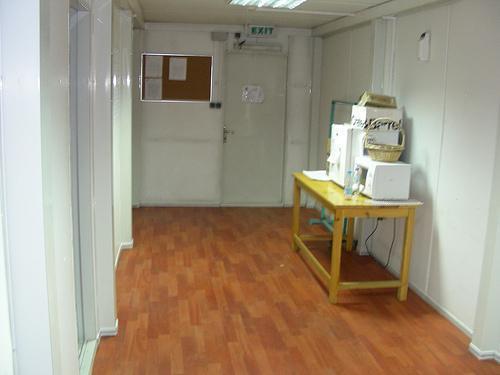How many notice board?
Give a very brief answer. 1. 